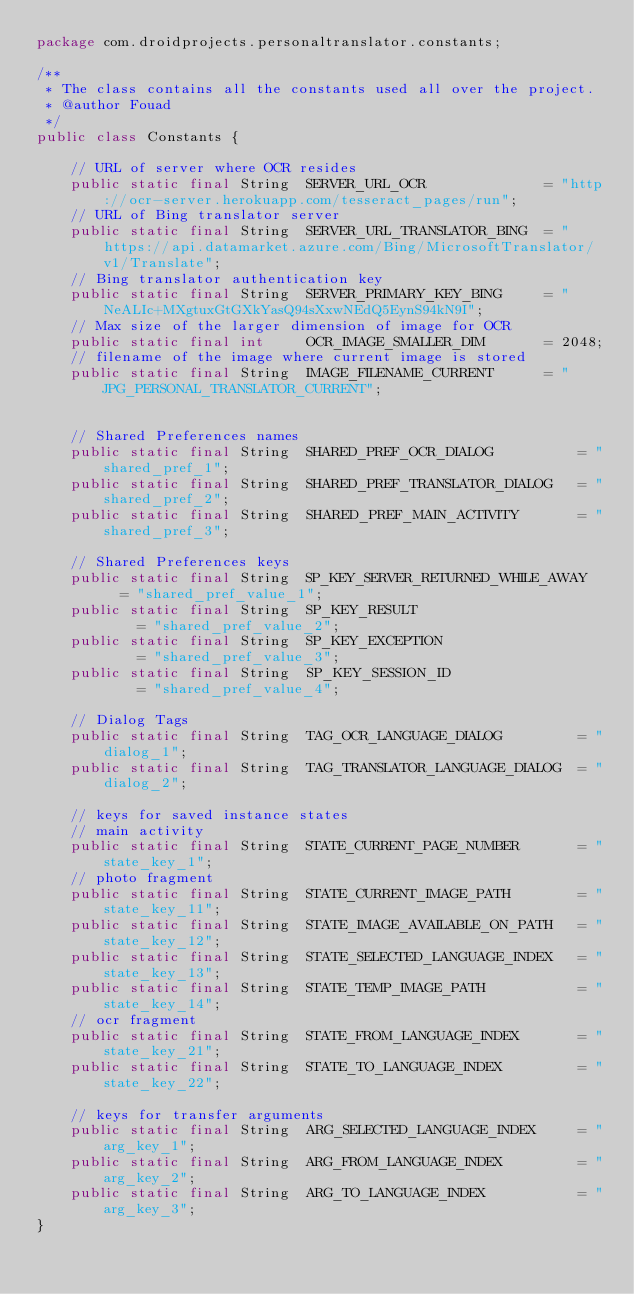Convert code to text. <code><loc_0><loc_0><loc_500><loc_500><_Java_>package com.droidprojects.personaltranslator.constants;

/**
 * The class contains all the constants used all over the project.
 * @author Fouad
 */
public class Constants {
	
	// URL of server where OCR resides
	public static final String 	SERVER_URL_OCR 				= "http://ocr-server.herokuapp.com/tesseract_pages/run";
	// URL of Bing translator server
	public static final String 	SERVER_URL_TRANSLATOR_BING	= "https://api.datamarket.azure.com/Bing/MicrosoftTranslator/v1/Translate";
	// Bing translator authentication key
	public static final String 	SERVER_PRIMARY_KEY_BING 	= "NeALIc+MXgtuxGtGXkYasQ94sXxwNEdQ5EynS94kN9I";
	// Max size of the larger dimension of image for OCR
	public static final int 	OCR_IMAGE_SMALLER_DIM 		= 2048;
	// filename of the image where current image is stored
	public static final String 	IMAGE_FILENAME_CURRENT 		= "JPG_PERSONAL_TRANSLATOR_CURRENT";
	
	
	// Shared Preferences names
	public static final String 	SHARED_PREF_OCR_DIALOG 			= "shared_pref_1";
	public static final String 	SHARED_PREF_TRANSLATOR_DIALOG 	= "shared_pref_2";
	public static final String 	SHARED_PREF_MAIN_ACTIVITY 		= "shared_pref_3";
	
	// Shared Preferences keys
	public static final String 	SP_KEY_SERVER_RETURNED_WHILE_AWAY 	= "shared_pref_value_1";
	public static final String 	SP_KEY_RESULT 						= "shared_pref_value_2";
	public static final String 	SP_KEY_EXCEPTION 					= "shared_pref_value_3";
	public static final String 	SP_KEY_SESSION_ID 					= "shared_pref_value_4";
	
	// Dialog Tags
	public static final String 	TAG_OCR_LANGUAGE_DIALOG 		= "dialog_1";
	public static final String 	TAG_TRANSLATOR_LANGUAGE_DIALOG	= "dialog_2";
	
	// keys for saved instance states
	// main activity
	public static final String 	STATE_CURRENT_PAGE_NUMBER 		= "state_key_1";
	// photo fragment
	public static final String 	STATE_CURRENT_IMAGE_PATH 		= "state_key_11";
	public static final String 	STATE_IMAGE_AVAILABLE_ON_PATH 	= "state_key_12";
	public static final String 	STATE_SELECTED_LANGUAGE_INDEX 	= "state_key_13";
	public static final String 	STATE_TEMP_IMAGE_PATH 			= "state_key_14";
	// ocr fragment
	public static final String 	STATE_FROM_LANGUAGE_INDEX 		= "state_key_21";
	public static final String 	STATE_TO_LANGUAGE_INDEX 		= "state_key_22";
	
	// keys for transfer arguments
	public static final String 	ARG_SELECTED_LANGUAGE_INDEX 	= "arg_key_1";
	public static final String 	ARG_FROM_LANGUAGE_INDEX 		= "arg_key_2";
	public static final String 	ARG_TO_LANGUAGE_INDEX 			= "arg_key_3";
}</code> 